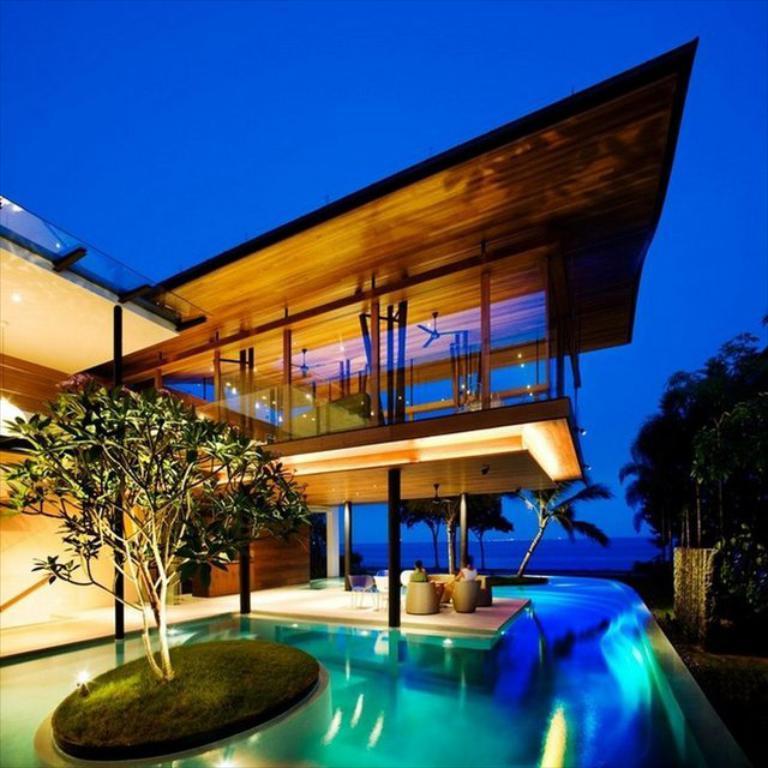Please provide a concise description of this image. On the left side it is the tree, at the bottom it is a swimming pool. In the middle it is a house, at the top it is the sky. 